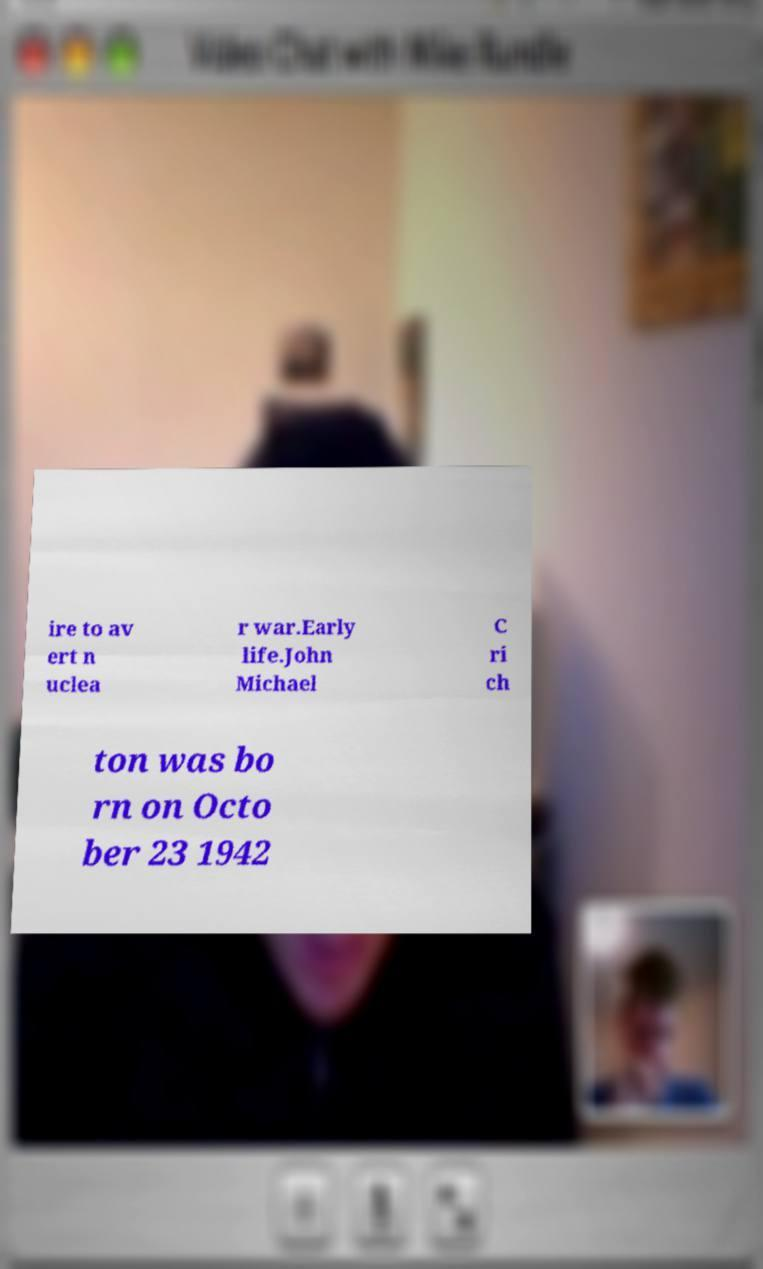Please identify and transcribe the text found in this image. ire to av ert n uclea r war.Early life.John Michael C ri ch ton was bo rn on Octo ber 23 1942 